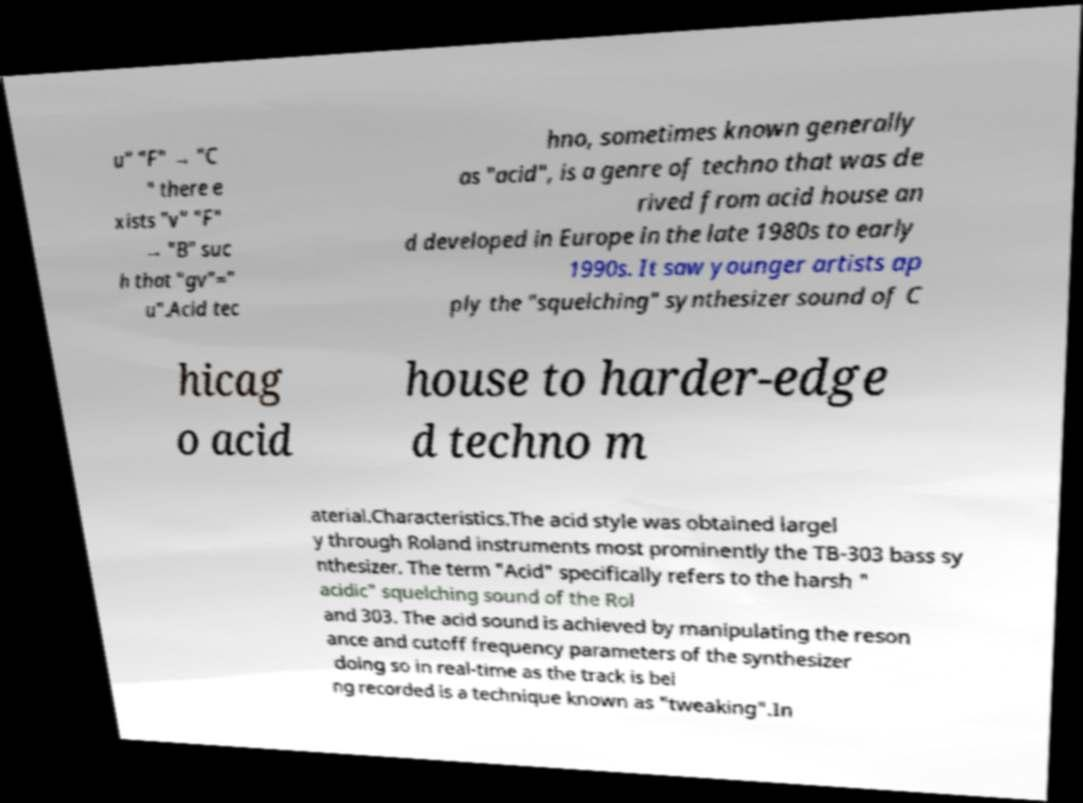Please identify and transcribe the text found in this image. u" "F" → "C " there e xists "v" "F" → "B" suc h that "gv"=" u".Acid tec hno, sometimes known generally as "acid", is a genre of techno that was de rived from acid house an d developed in Europe in the late 1980s to early 1990s. It saw younger artists ap ply the "squelching" synthesizer sound of C hicag o acid house to harder-edge d techno m aterial.Characteristics.The acid style was obtained largel y through Roland instruments most prominently the TB-303 bass sy nthesizer. The term "Acid" specifically refers to the harsh " acidic" squelching sound of the Rol and 303. The acid sound is achieved by manipulating the reson ance and cutoff frequency parameters of the synthesizer doing so in real-time as the track is bei ng recorded is a technique known as "tweaking".In 